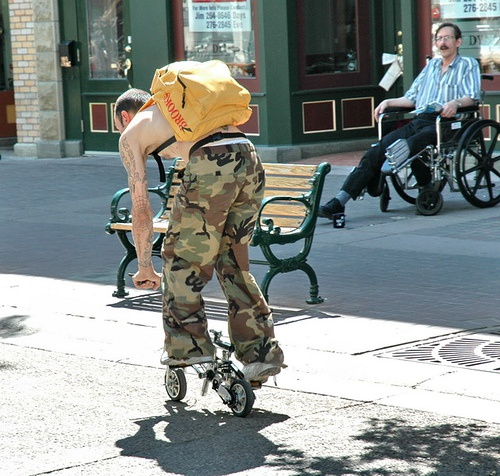Describe the objects in this image and their specific colors. I can see people in darkgreen, gray, tan, and black tones, people in darkgreen, black, gray, lightblue, and darkgray tones, bench in darkgreen, black, gray, and tan tones, chair in darkgreen, black, gray, and purple tones, and backpack in darkgreen, tan, ivory, and khaki tones in this image. 